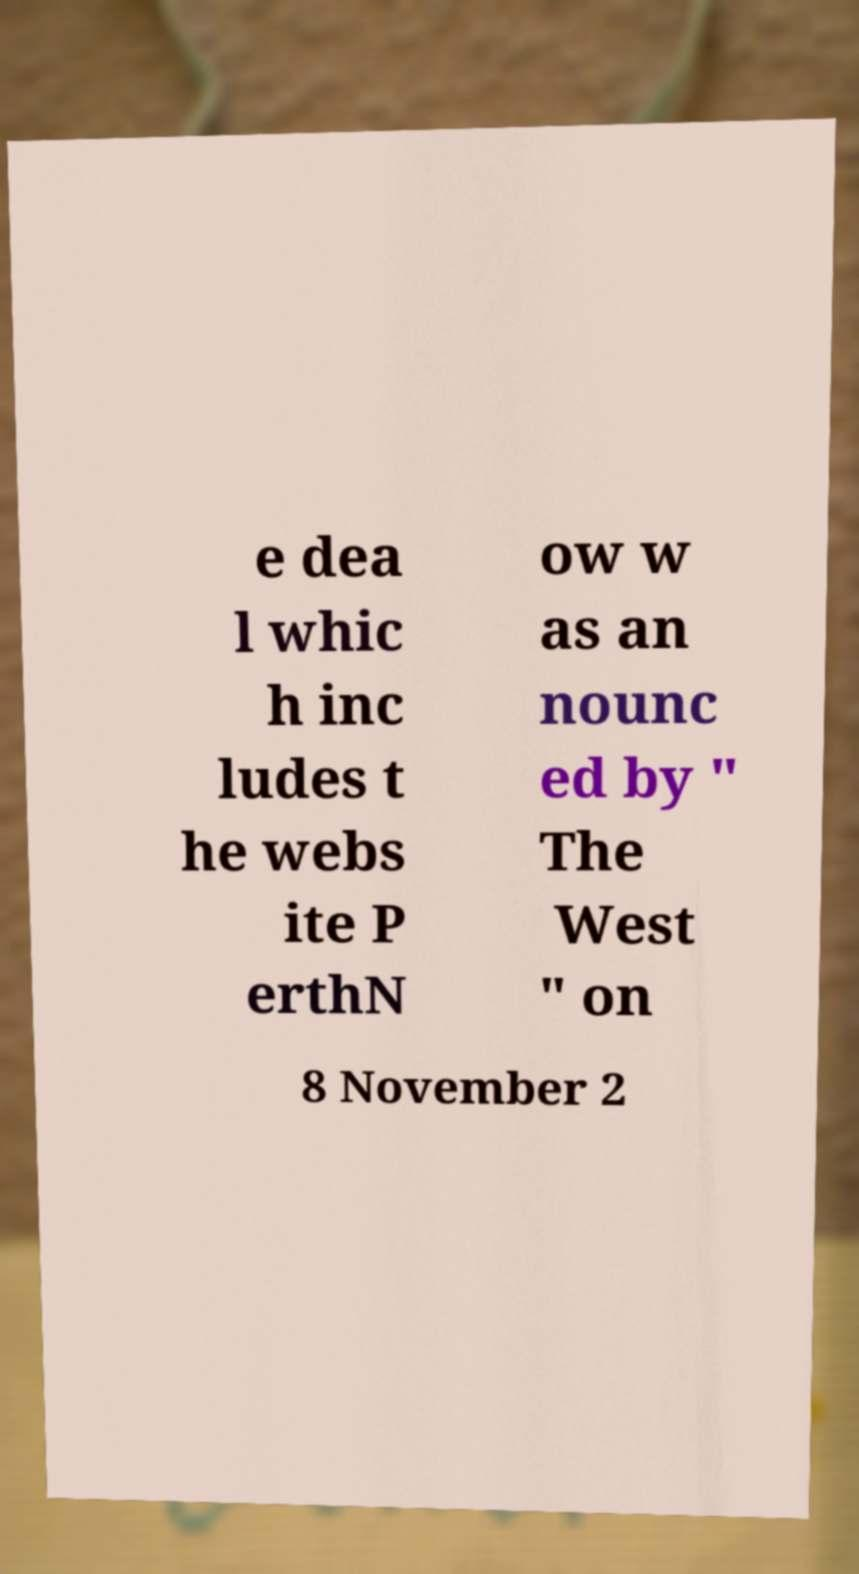Please identify and transcribe the text found in this image. e dea l whic h inc ludes t he webs ite P erthN ow w as an nounc ed by " The West " on 8 November 2 